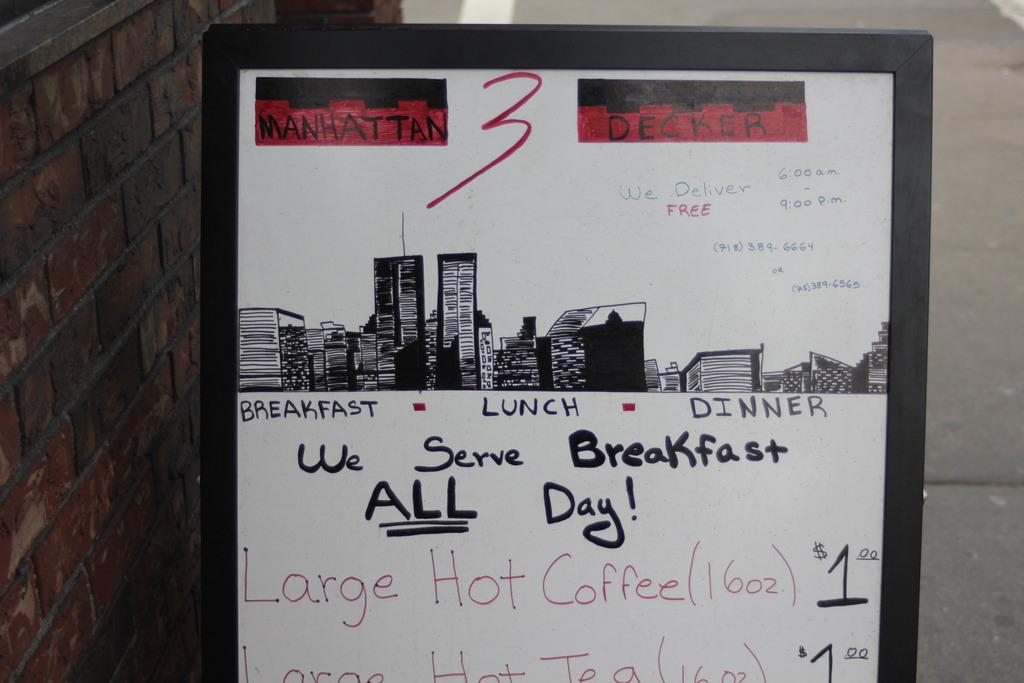<image>
Render a clear and concise summary of the photo. Sign that lets customers know that the restaurant serves breakfast all day. 